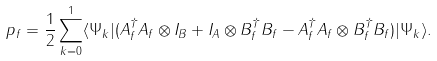<formula> <loc_0><loc_0><loc_500><loc_500>p _ { f } = \frac { 1 } { 2 } \sum _ { k = 0 } ^ { 1 } \langle \Psi _ { k } | ( A _ { f } ^ { \dagger } A _ { f } \otimes I _ { B } + I _ { A } \otimes B _ { f } ^ { \dagger } B _ { f } - A _ { f } ^ { \dagger } A _ { f } \otimes B _ { f } ^ { \dagger } B _ { f } ) | \Psi _ { k } \rangle .</formula> 